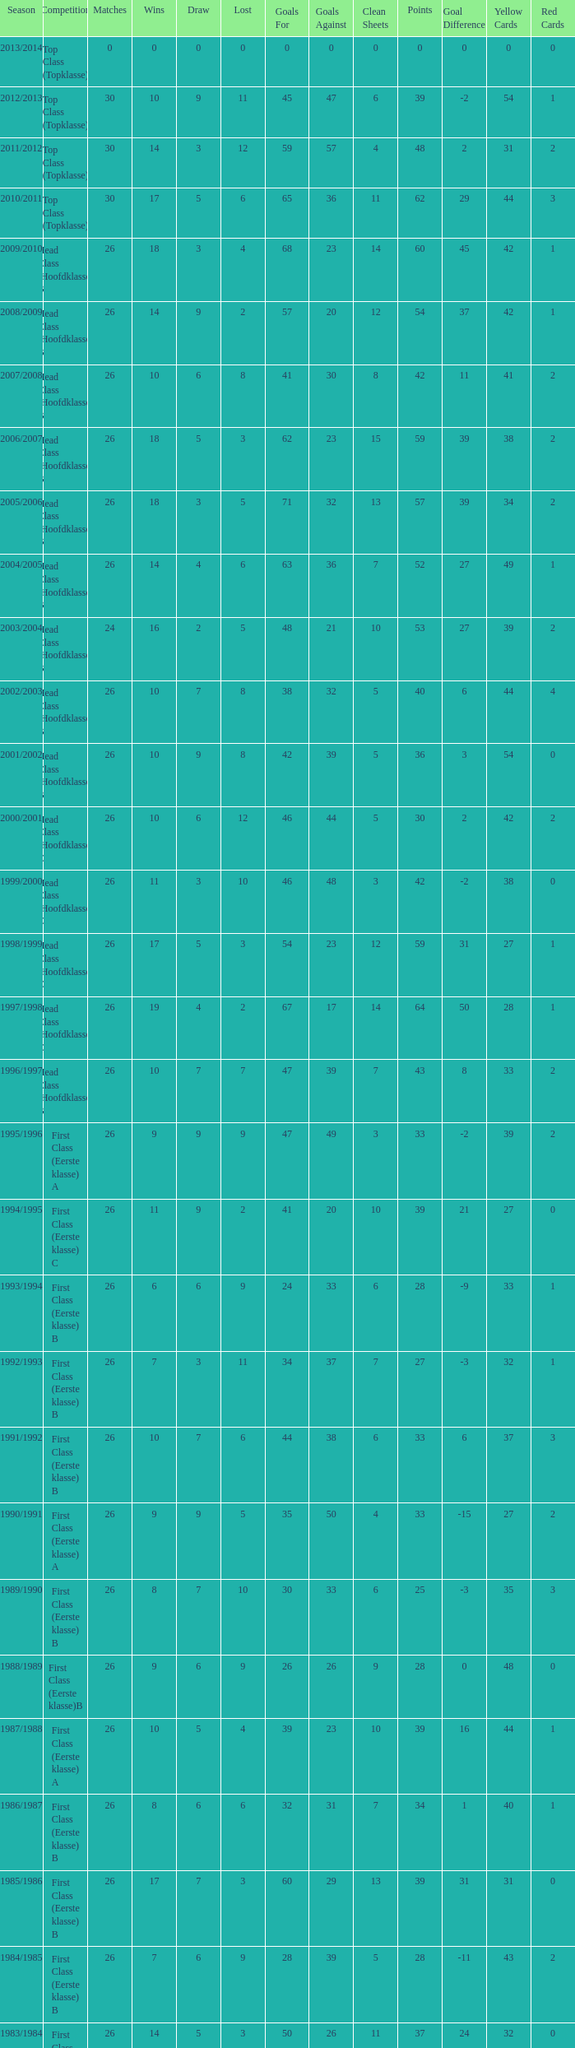What competition has a score greater than 30, a draw less than 5, and a loss larger than 10? Top Class (Topklasse). 